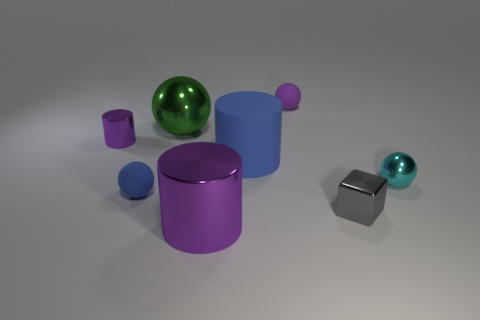Can you describe the position of the largest purple object in relation to the other objects? The largest purple object, which appears to be a cylinder, is centrally located among the other objects. It's nestled between the two balls, one purple and one teal, and is to the left of the gray shiny cube. 